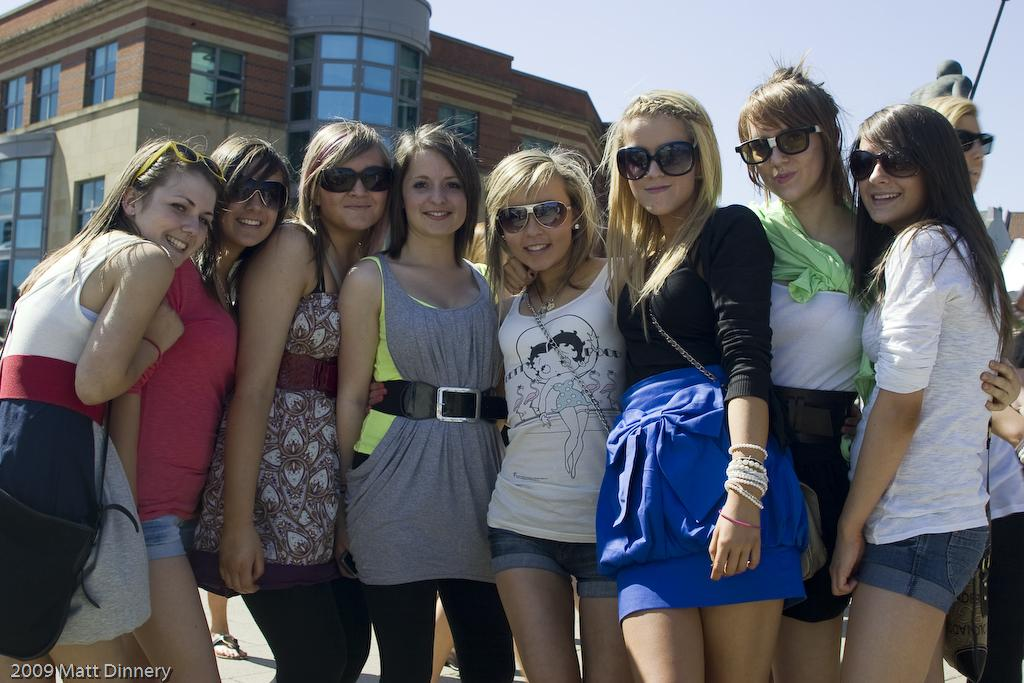How many people are in the image? There is a group of people in the image, but the exact number is not specified. What are the people in the image doing? The people are standing in the image. What can be seen in the background of the image? There is a building and a sculpture in the background of the image. What is visible at the top of the image? The sky is visible in the image. How many snails are crawling on the people in the image? There are no snails present in the image; it features a group of people standing with a background of a building and a sculpture. What type of flock is flying in the sky in the image? There is no flock of birds or any other animals visible in the sky in the image. 